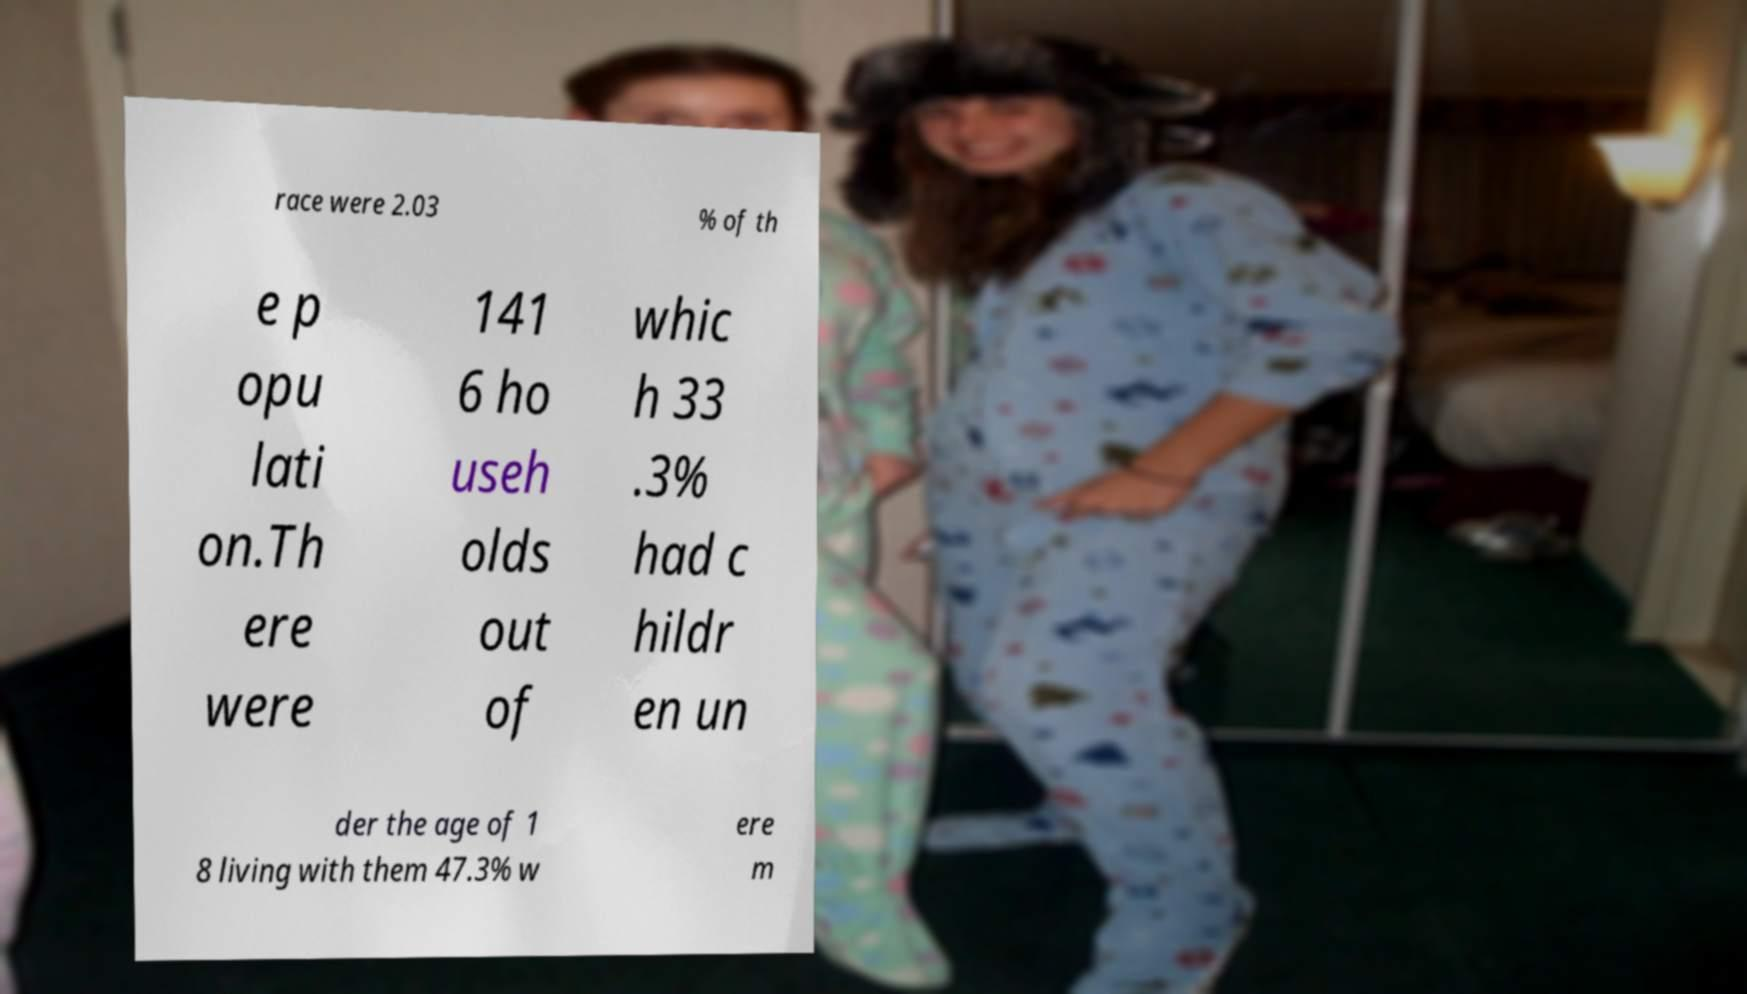What messages or text are displayed in this image? I need them in a readable, typed format. race were 2.03 % of th e p opu lati on.Th ere were 141 6 ho useh olds out of whic h 33 .3% had c hildr en un der the age of 1 8 living with them 47.3% w ere m 